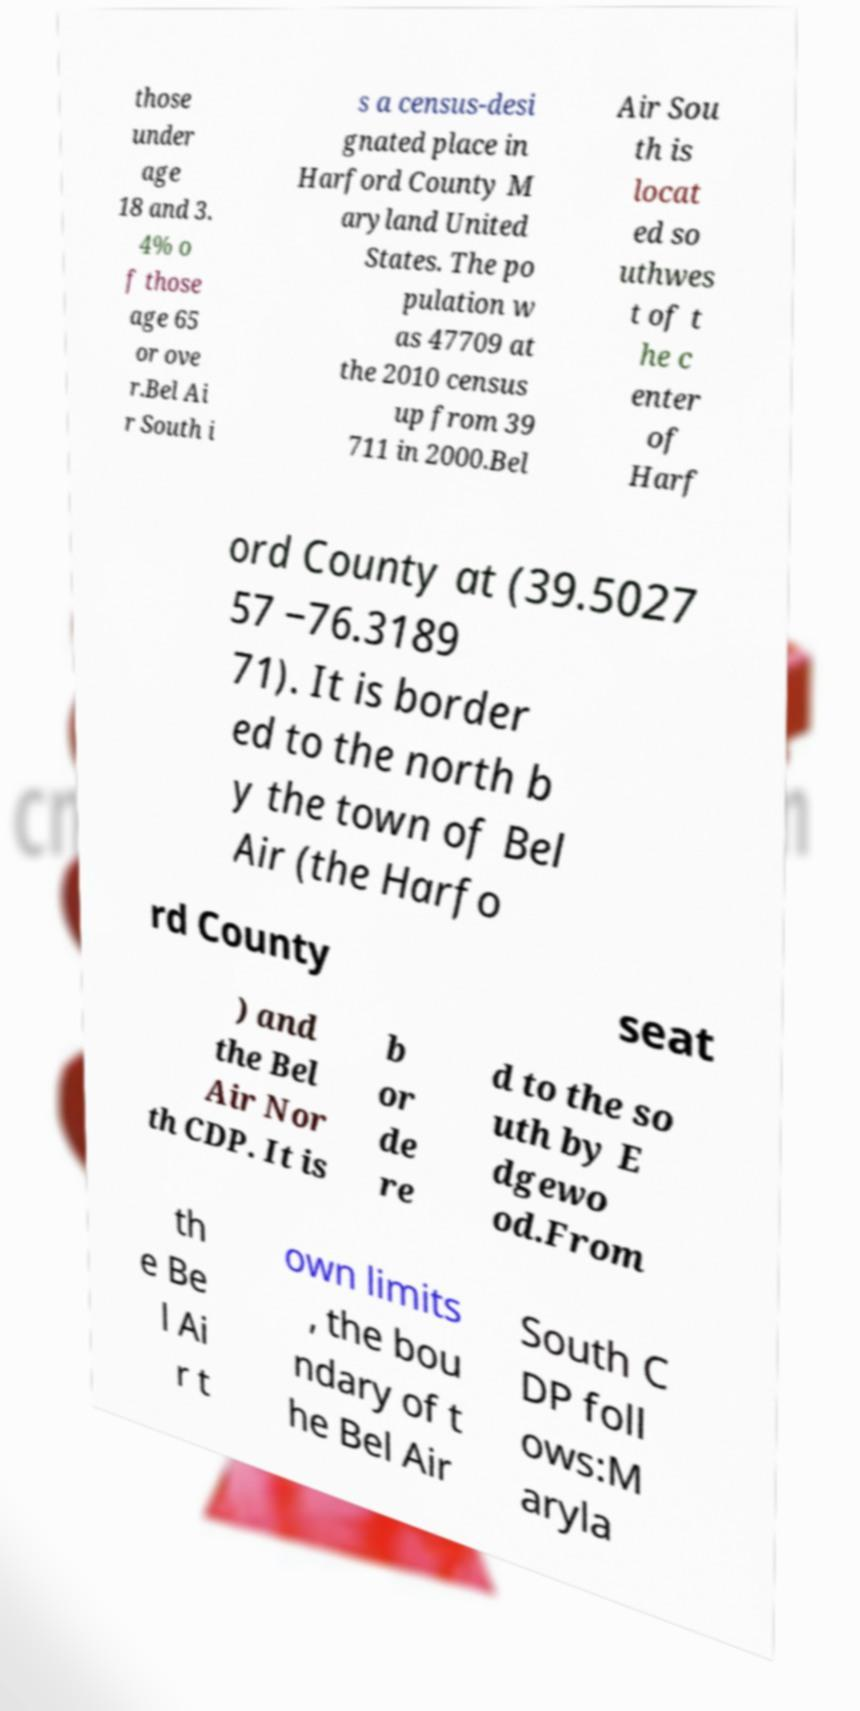Could you assist in decoding the text presented in this image and type it out clearly? those under age 18 and 3. 4% o f those age 65 or ove r.Bel Ai r South i s a census-desi gnated place in Harford County M aryland United States. The po pulation w as 47709 at the 2010 census up from 39 711 in 2000.Bel Air Sou th is locat ed so uthwes t of t he c enter of Harf ord County at (39.5027 57 −76.3189 71). It is border ed to the north b y the town of Bel Air (the Harfo rd County seat ) and the Bel Air Nor th CDP. It is b or de re d to the so uth by E dgewo od.From th e Be l Ai r t own limits , the bou ndary of t he Bel Air South C DP foll ows:M aryla 